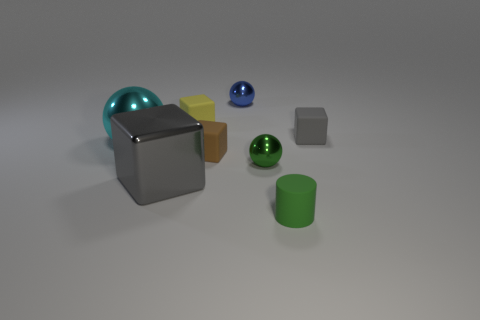There is a blue thing that is made of the same material as the big cyan object; what shape is it?
Make the answer very short. Sphere. How many green objects are either cylinders or tiny shiny cubes?
Make the answer very short. 1. There is a tiny green rubber thing; are there any yellow blocks to the right of it?
Offer a terse response. No. There is a tiny green object that is on the right side of the small green metallic object; is it the same shape as the gray thing behind the large cyan object?
Your answer should be very brief. No. There is a small yellow thing that is the same shape as the small brown rubber thing; what material is it?
Your response must be concise. Rubber. How many cubes are either green matte things or yellow matte objects?
Ensure brevity in your answer.  1. How many tiny brown objects are made of the same material as the small gray block?
Give a very brief answer. 1. Are the gray object in front of the small green ball and the gray cube right of the big gray shiny object made of the same material?
Provide a succinct answer. No. There is a green thing that is behind the big metal thing on the right side of the cyan object; how many yellow rubber things are in front of it?
Ensure brevity in your answer.  0. There is a thing in front of the big gray shiny thing; does it have the same color as the small metallic sphere that is in front of the small yellow thing?
Provide a short and direct response. Yes. 